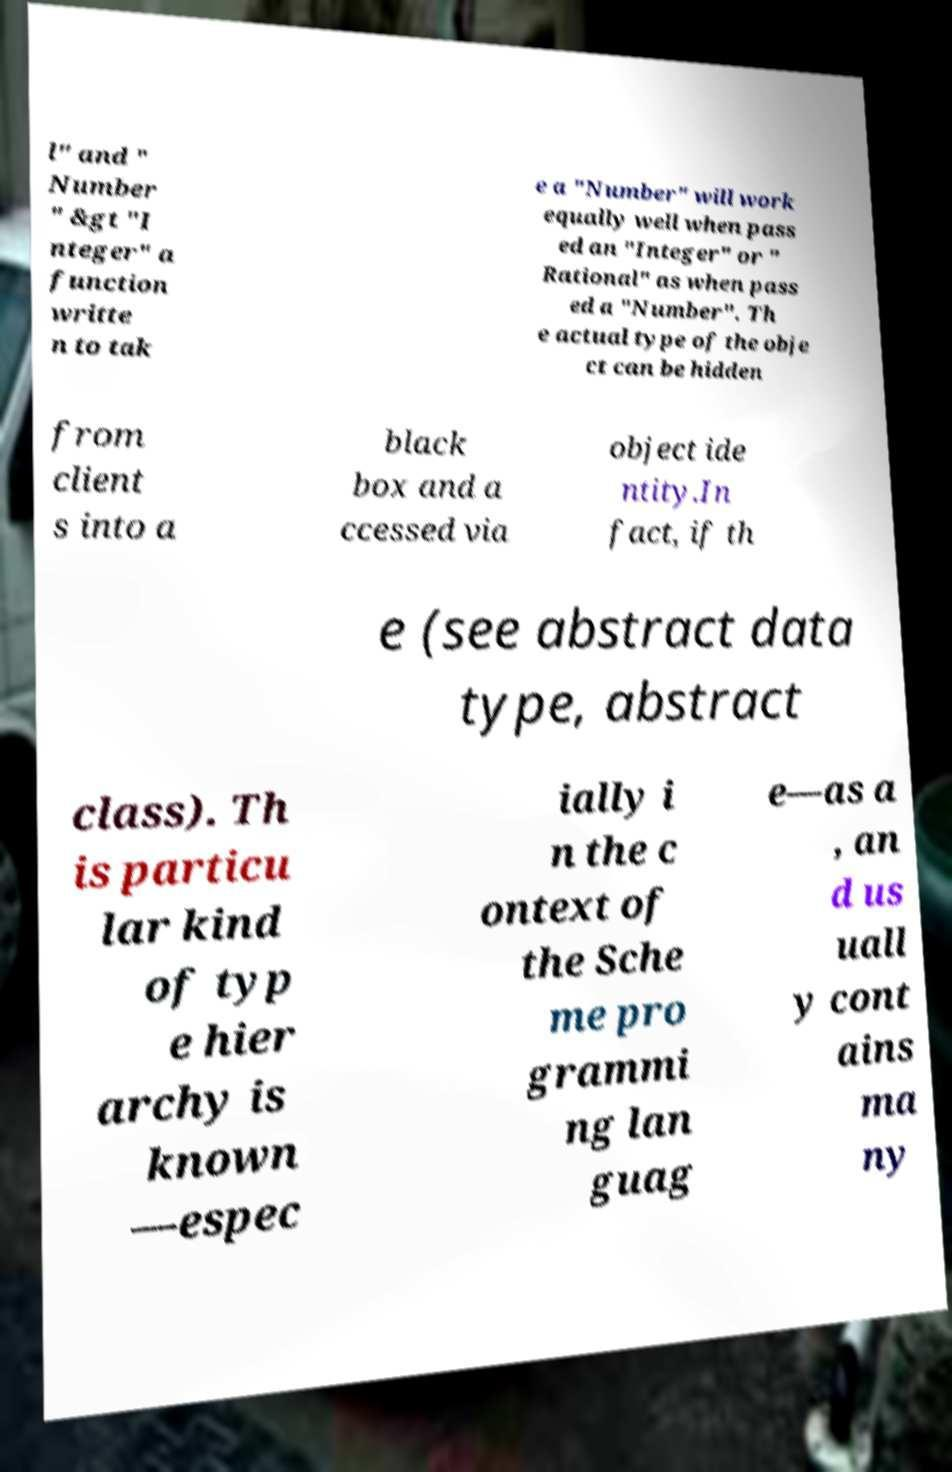Please read and relay the text visible in this image. What does it say? l" and " Number " &gt "I nteger" a function writte n to tak e a "Number" will work equally well when pass ed an "Integer" or " Rational" as when pass ed a "Number". Th e actual type of the obje ct can be hidden from client s into a black box and a ccessed via object ide ntity.In fact, if th e (see abstract data type, abstract class). Th is particu lar kind of typ e hier archy is known —espec ially i n the c ontext of the Sche me pro grammi ng lan guag e—as a , an d us uall y cont ains ma ny 